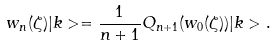<formula> <loc_0><loc_0><loc_500><loc_500>w _ { n } ( \zeta ) | k > = \frac { 1 } { n + 1 } Q _ { n + 1 } ( w _ { 0 } ( \zeta ) ) | k > .</formula> 